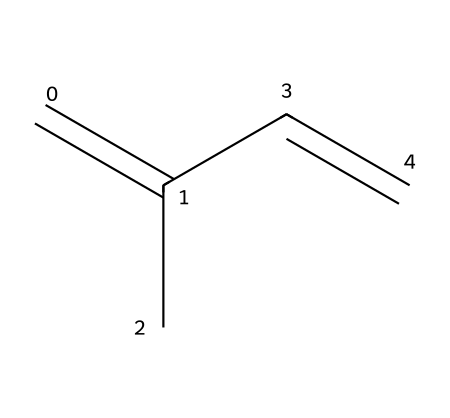What is the name of this hydrocarbon? The chemical structure shows a configuration associated with isoprene, which is a common hydrocarbon found in natural rubber.
Answer: isoprene How many double bonds are in isoprene? The structure contains two double bonds, indicated by the C=C notations present in the SMILES representation.
Answer: 2 How many carbon atoms are in isoprene? The molecular structure includes five carbon atoms, which can be counted from the SMILES representation (C=C(C)C=C).
Answer: 5 What type of hydrocarbon is isoprene? Isoprene is classified as a diene because it contains two double bonds within its structure.
Answer: diene What is the molecular formula of isoprene? By counting the atoms from the SMILES representation, we determine the molecular formula to be C5H8, consisting of five carbons and eight hydrogens.
Answer: C5H8 Why is isoprene significant in the production of natural rubber? Isoprene is significant because it polymerizes to form polyisoprene, the primary component of natural rubber, essential for flexibility and durability in instrument components.
Answer: polyisoprene What kind of interaction occurs between isoprene units in rubber? The interactions between isoprene units in rubber primarily involve covalent bonding during polymerization, leading to a flexible and elastic material.
Answer: covalent bonding 